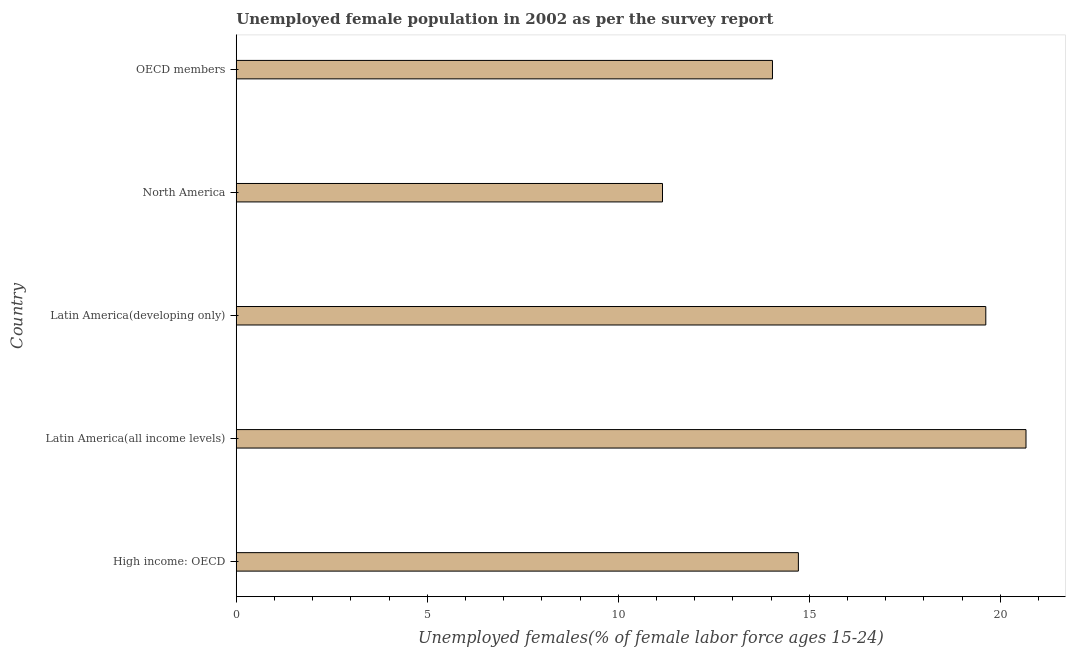Does the graph contain grids?
Your answer should be very brief. No. What is the title of the graph?
Give a very brief answer. Unemployed female population in 2002 as per the survey report. What is the label or title of the X-axis?
Your answer should be compact. Unemployed females(% of female labor force ages 15-24). What is the unemployed female youth in High income: OECD?
Provide a succinct answer. 14.71. Across all countries, what is the maximum unemployed female youth?
Offer a terse response. 20.67. Across all countries, what is the minimum unemployed female youth?
Your answer should be very brief. 11.16. In which country was the unemployed female youth maximum?
Your response must be concise. Latin America(all income levels). In which country was the unemployed female youth minimum?
Your answer should be very brief. North America. What is the sum of the unemployed female youth?
Provide a short and direct response. 80.2. What is the difference between the unemployed female youth in High income: OECD and OECD members?
Provide a succinct answer. 0.68. What is the average unemployed female youth per country?
Your answer should be very brief. 16.04. What is the median unemployed female youth?
Provide a short and direct response. 14.71. In how many countries, is the unemployed female youth greater than 4 %?
Ensure brevity in your answer.  5. What is the ratio of the unemployed female youth in High income: OECD to that in OECD members?
Keep it short and to the point. 1.05. Is the unemployed female youth in High income: OECD less than that in OECD members?
Provide a succinct answer. No. Is the difference between the unemployed female youth in High income: OECD and North America greater than the difference between any two countries?
Your response must be concise. No. What is the difference between the highest and the second highest unemployed female youth?
Your response must be concise. 1.05. Is the sum of the unemployed female youth in Latin America(developing only) and OECD members greater than the maximum unemployed female youth across all countries?
Offer a very short reply. Yes. What is the difference between the highest and the lowest unemployed female youth?
Keep it short and to the point. 9.51. How many bars are there?
Ensure brevity in your answer.  5. What is the Unemployed females(% of female labor force ages 15-24) in High income: OECD?
Provide a succinct answer. 14.71. What is the Unemployed females(% of female labor force ages 15-24) of Latin America(all income levels)?
Your answer should be very brief. 20.67. What is the Unemployed females(% of female labor force ages 15-24) of Latin America(developing only)?
Offer a very short reply. 19.62. What is the Unemployed females(% of female labor force ages 15-24) of North America?
Ensure brevity in your answer.  11.16. What is the Unemployed females(% of female labor force ages 15-24) in OECD members?
Ensure brevity in your answer.  14.04. What is the difference between the Unemployed females(% of female labor force ages 15-24) in High income: OECD and Latin America(all income levels)?
Keep it short and to the point. -5.96. What is the difference between the Unemployed females(% of female labor force ages 15-24) in High income: OECD and Latin America(developing only)?
Offer a very short reply. -4.91. What is the difference between the Unemployed females(% of female labor force ages 15-24) in High income: OECD and North America?
Give a very brief answer. 3.56. What is the difference between the Unemployed females(% of female labor force ages 15-24) in High income: OECD and OECD members?
Provide a succinct answer. 0.68. What is the difference between the Unemployed females(% of female labor force ages 15-24) in Latin America(all income levels) and Latin America(developing only)?
Your answer should be compact. 1.05. What is the difference between the Unemployed females(% of female labor force ages 15-24) in Latin America(all income levels) and North America?
Offer a very short reply. 9.51. What is the difference between the Unemployed females(% of female labor force ages 15-24) in Latin America(all income levels) and OECD members?
Keep it short and to the point. 6.64. What is the difference between the Unemployed females(% of female labor force ages 15-24) in Latin America(developing only) and North America?
Your answer should be very brief. 8.46. What is the difference between the Unemployed females(% of female labor force ages 15-24) in Latin America(developing only) and OECD members?
Provide a succinct answer. 5.58. What is the difference between the Unemployed females(% of female labor force ages 15-24) in North America and OECD members?
Provide a short and direct response. -2.88. What is the ratio of the Unemployed females(% of female labor force ages 15-24) in High income: OECD to that in Latin America(all income levels)?
Your response must be concise. 0.71. What is the ratio of the Unemployed females(% of female labor force ages 15-24) in High income: OECD to that in Latin America(developing only)?
Provide a short and direct response. 0.75. What is the ratio of the Unemployed females(% of female labor force ages 15-24) in High income: OECD to that in North America?
Provide a succinct answer. 1.32. What is the ratio of the Unemployed females(% of female labor force ages 15-24) in High income: OECD to that in OECD members?
Your answer should be compact. 1.05. What is the ratio of the Unemployed females(% of female labor force ages 15-24) in Latin America(all income levels) to that in Latin America(developing only)?
Offer a terse response. 1.05. What is the ratio of the Unemployed females(% of female labor force ages 15-24) in Latin America(all income levels) to that in North America?
Your response must be concise. 1.85. What is the ratio of the Unemployed females(% of female labor force ages 15-24) in Latin America(all income levels) to that in OECD members?
Make the answer very short. 1.47. What is the ratio of the Unemployed females(% of female labor force ages 15-24) in Latin America(developing only) to that in North America?
Your answer should be compact. 1.76. What is the ratio of the Unemployed females(% of female labor force ages 15-24) in Latin America(developing only) to that in OECD members?
Provide a succinct answer. 1.4. What is the ratio of the Unemployed females(% of female labor force ages 15-24) in North America to that in OECD members?
Your answer should be compact. 0.8. 